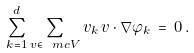Convert formula to latex. <formula><loc_0><loc_0><loc_500><loc_500>\sum _ { k = 1 } ^ { d } \sum _ { v \in \ m c V } v _ { k } \, v \cdot \nabla \varphi _ { k } \, = \, 0 \, .</formula> 